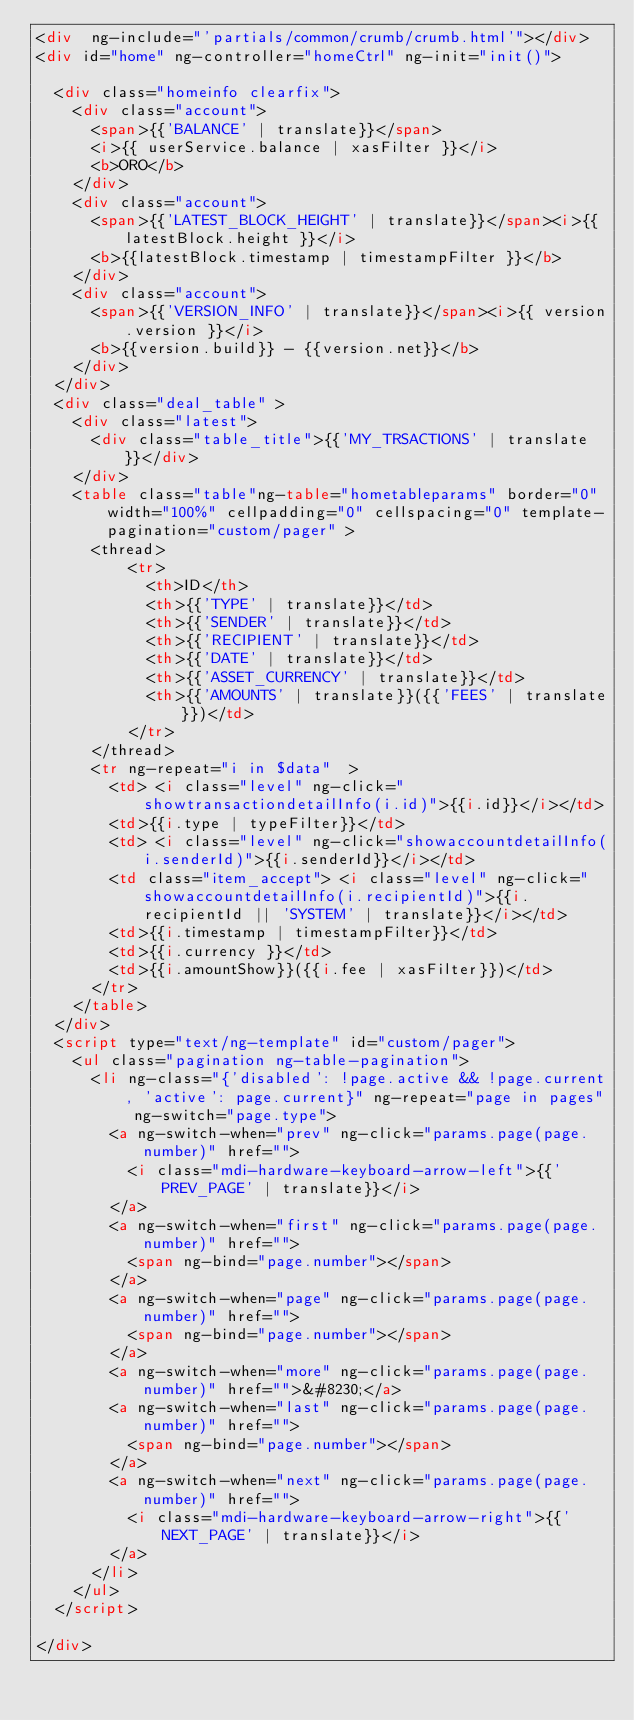<code> <loc_0><loc_0><loc_500><loc_500><_HTML_><div  ng-include="'partials/common/crumb/crumb.html'"></div>
<div id="home" ng-controller="homeCtrl" ng-init="init()">

	<div class="homeinfo clearfix">
		<div class="account">
			<span>{{'BALANCE' | translate}}</span>
			<i>{{ userService.balance | xasFilter }}</i>
			<b>ORO</b>
		</div>
		<div class="account">
			<span>{{'LATEST_BLOCK_HEIGHT' | translate}}</span><i>{{ latestBlock.height }}</i>
			<b>{{latestBlock.timestamp | timestampFilter }}</b>
		</div>
		<div class="account">
			<span>{{'VERSION_INFO' | translate}}</span><i>{{ version.version }}</i>
			<b>{{version.build}} - {{version.net}}</b>
		</div>
	</div>
	<div class="deal_table" >
		<div class="latest">
			<div class="table_title">{{'MY_TRSACTIONS' | translate}}</div>
		</div>
		<table class="table"ng-table="hometableparams" border="0" width="100%" cellpadding="0" cellspacing="0" template-pagination="custom/pager" >
			<thread>
					<tr>
						<th>ID</th>
						<th>{{'TYPE' | translate}}</td>
						<th>{{'SENDER' | translate}}</td>
						<th>{{'RECIPIENT' | translate}}</td>
						<th>{{'DATE' | translate}}</td>
						<th>{{'ASSET_CURRENCY' | translate}}</td>	
						<th>{{'AMOUNTS' | translate}}({{'FEES' | translate}})</td>
					</tr>
			</thread>
			<tr ng-repeat="i in $data"  >
				<td> <i class="level" ng-click="showtransactiondetailInfo(i.id)">{{i.id}}</i></td>
				<td>{{i.type | typeFilter}}</td>
				<td> <i class="level" ng-click="showaccountdetailInfo(i.senderId)">{{i.senderId}}</i></td>
				<td class="item_accept"> <i class="level" ng-click="showaccountdetailInfo(i.recipientId)">{{i.recipientId || 'SYSTEM' | translate}}</i></td>
				<td>{{i.timestamp | timestampFilter}}</td>
				<td>{{i.currency }}</td>
				<td>{{i.amountShow}}({{i.fee | xasFilter}})</td>
			</tr>
		</table>
	</div>
	<script type="text/ng-template" id="custom/pager">
		<ul class="pagination ng-table-pagination">
			<li ng-class="{'disabled': !page.active && !page.current, 'active': page.current}" ng-repeat="page in pages" ng-switch="page.type">
				<a ng-switch-when="prev" ng-click="params.page(page.number)" href="">
					<i class="mdi-hardware-keyboard-arrow-left">{{'PREV_PAGE' | translate}}</i>
				</a>
				<a ng-switch-when="first" ng-click="params.page(page.number)" href="">
					<span ng-bind="page.number"></span>
				</a>
				<a ng-switch-when="page" ng-click="params.page(page.number)" href="">
					<span ng-bind="page.number"></span>
				</a>
				<a ng-switch-when="more" ng-click="params.page(page.number)" href="">&#8230;</a>
				<a ng-switch-when="last" ng-click="params.page(page.number)" href="">
					<span ng-bind="page.number"></span>
				</a>
				<a ng-switch-when="next" ng-click="params.page(page.number)" href="">
					<i class="mdi-hardware-keyboard-arrow-right">{{'NEXT_PAGE' | translate}}</i>
				</a>
			</li>
		</ul>
	</script>

</div></code> 